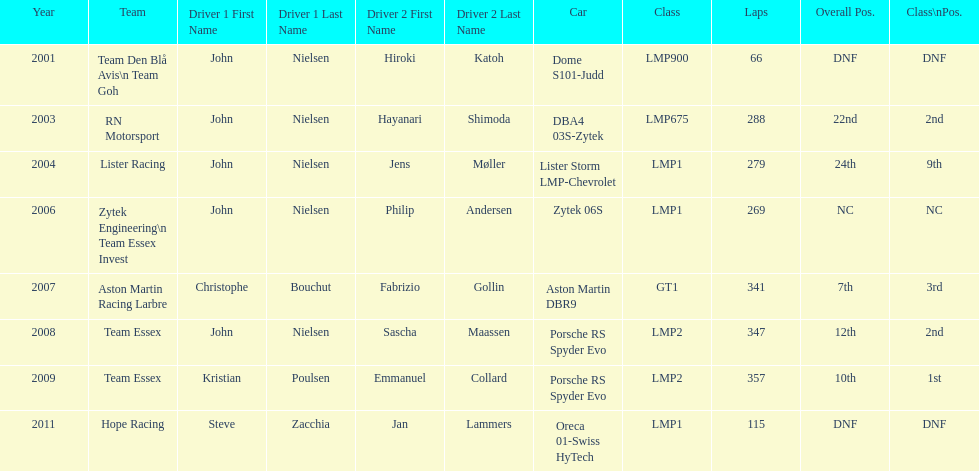Who were the co-drivers for the aston martin dbr9 in 2007? Christophe Bouchut, Fabrizio Gollin. 